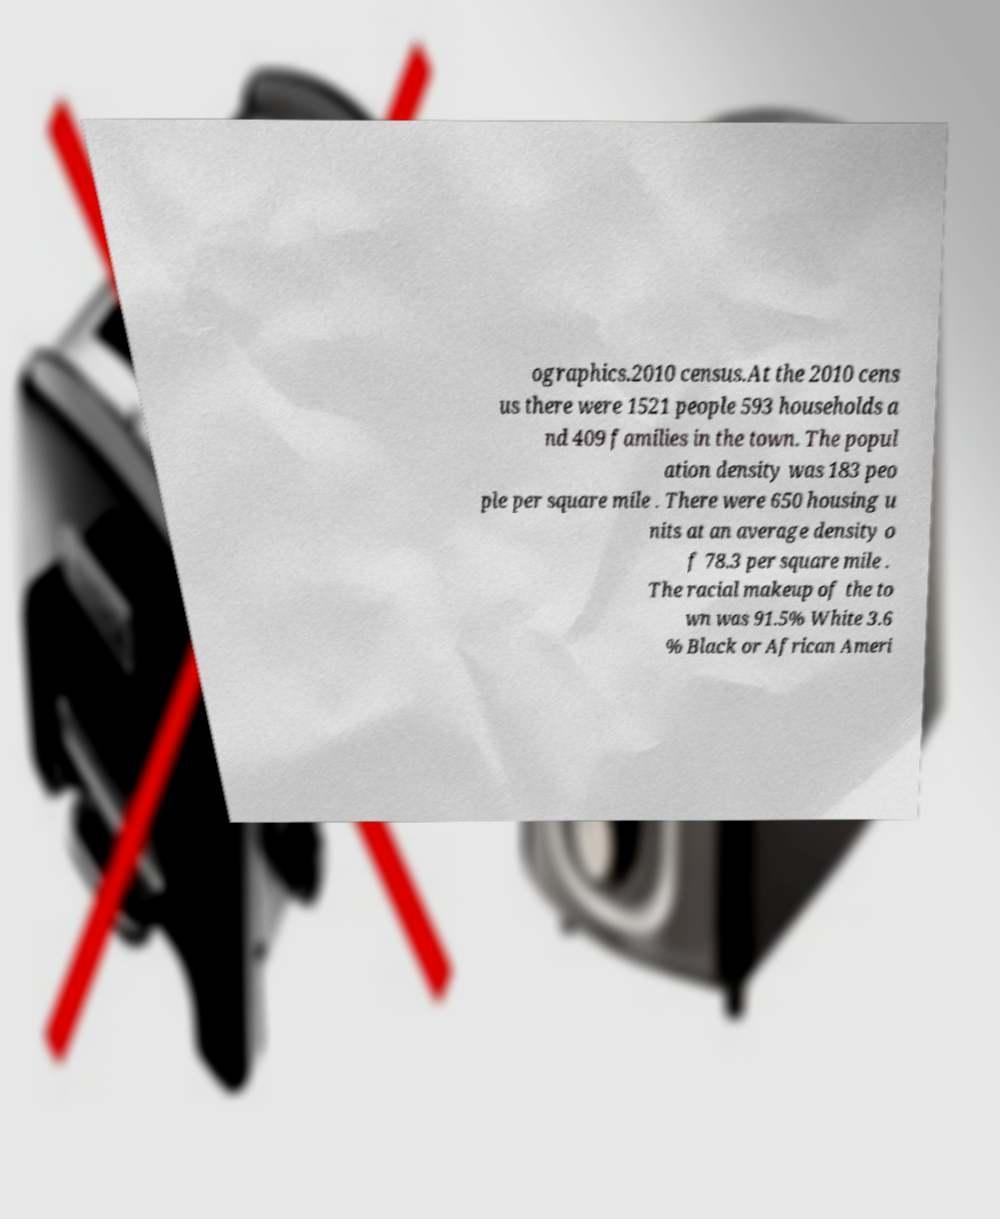Please identify and transcribe the text found in this image. ographics.2010 census.At the 2010 cens us there were 1521 people 593 households a nd 409 families in the town. The popul ation density was 183 peo ple per square mile . There were 650 housing u nits at an average density o f 78.3 per square mile . The racial makeup of the to wn was 91.5% White 3.6 % Black or African Ameri 